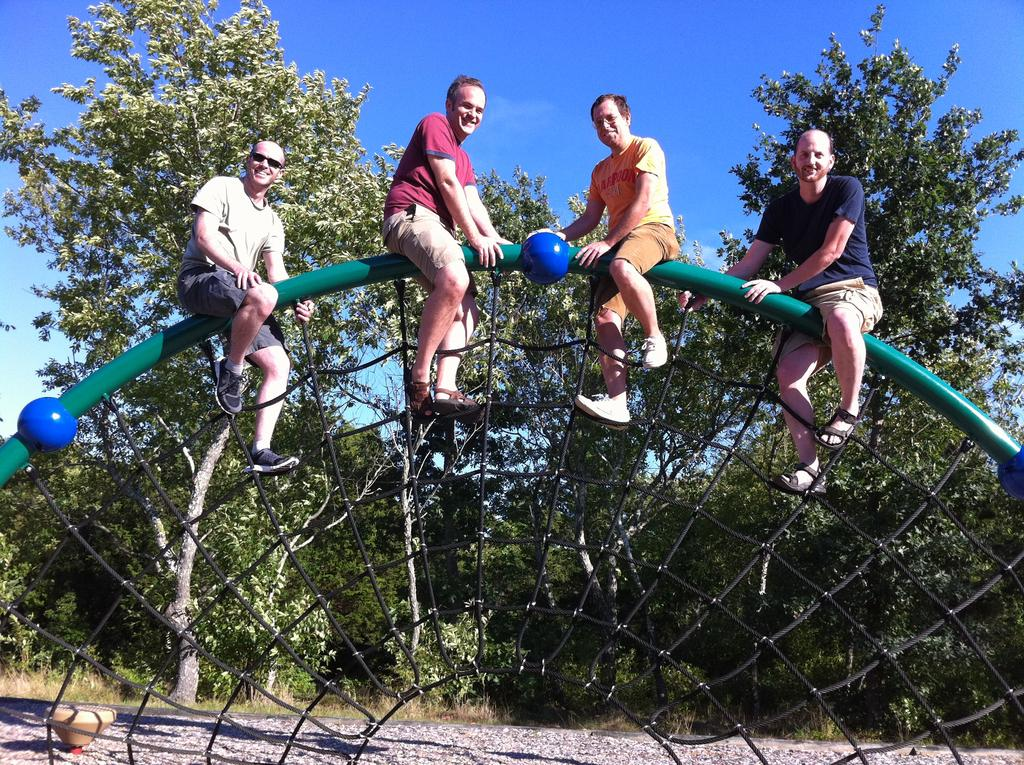How many people are sitting on the rod in the image? There are four people sitting on the rod in the image. What can be seen behind the people? There are trees behind the people. What is visible in the background of the image? The sky is visible in the background of the image. What is located at the bottom of the image? There is a road at the bottom of the image. What type of door can be seen in the image? There is no door present in the image. Can you describe the toad's behavior in the image? There is no toad present in the image. 